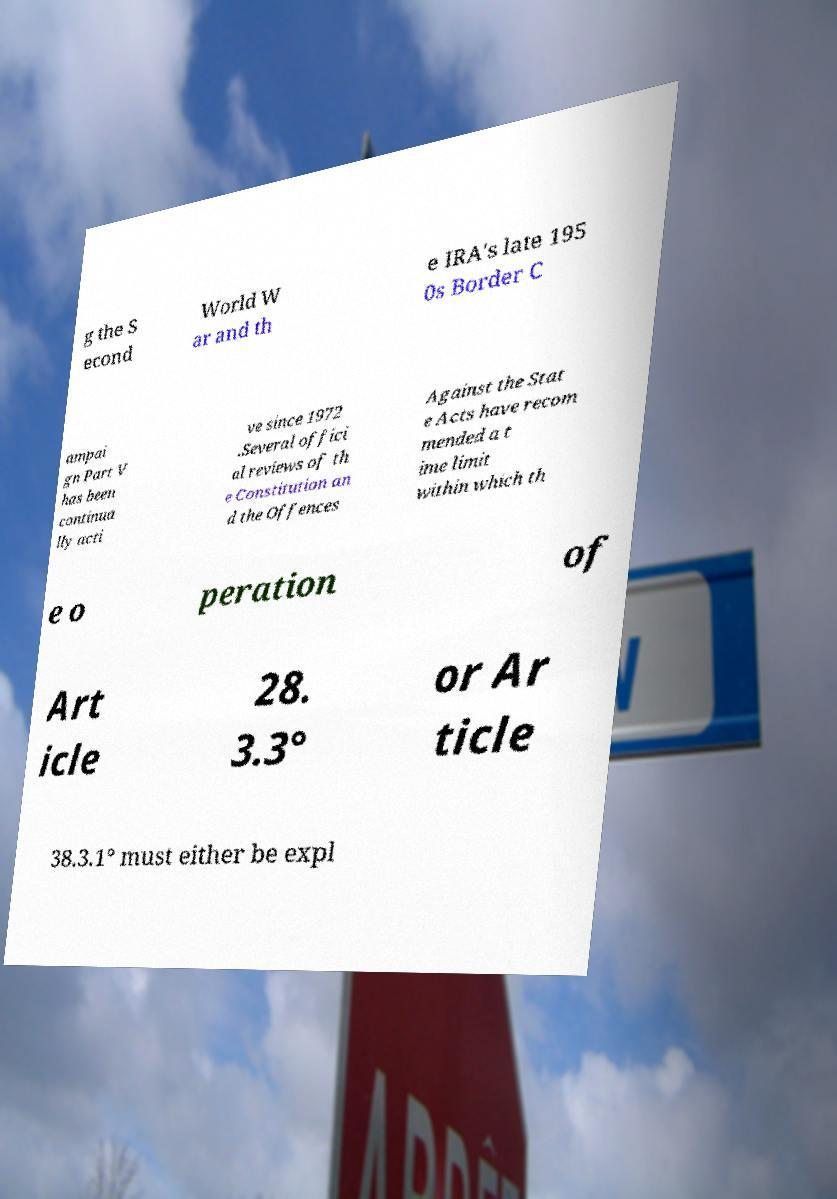Can you read and provide the text displayed in the image?This photo seems to have some interesting text. Can you extract and type it out for me? g the S econd World W ar and th e IRA's late 195 0s Border C ampai gn Part V has been continua lly acti ve since 1972 .Several offici al reviews of th e Constitution an d the Offences Against the Stat e Acts have recom mended a t ime limit within which th e o peration of Art icle 28. 3.3° or Ar ticle 38.3.1° must either be expl 